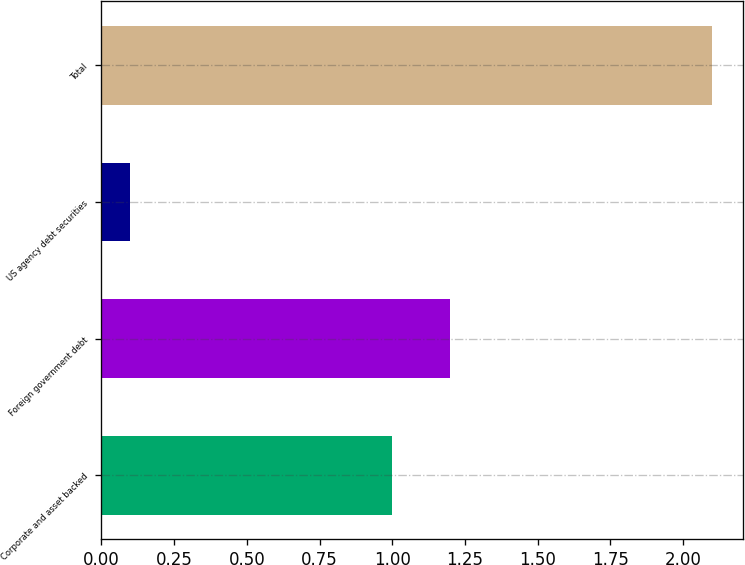Convert chart. <chart><loc_0><loc_0><loc_500><loc_500><bar_chart><fcel>Corporate and asset backed<fcel>Foreign government debt<fcel>US agency debt securities<fcel>Total<nl><fcel>1<fcel>1.2<fcel>0.1<fcel>2.1<nl></chart> 